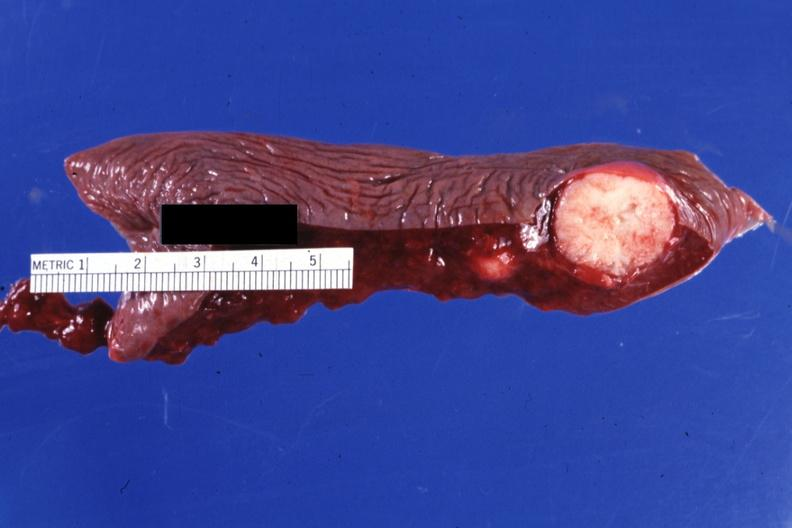what is present?
Answer the question using a single word or phrase. Metastatic carcinoma breast 